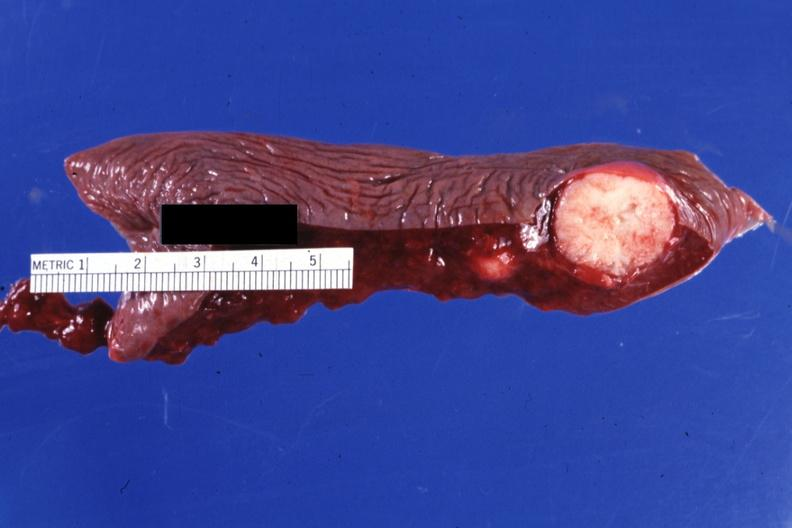what is present?
Answer the question using a single word or phrase. Metastatic carcinoma breast 